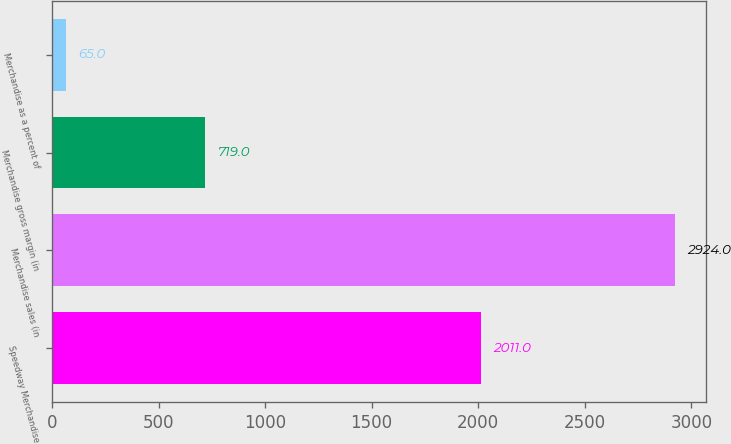Convert chart. <chart><loc_0><loc_0><loc_500><loc_500><bar_chart><fcel>Speedway Merchandise<fcel>Merchandise sales (in<fcel>Merchandise gross margin (in<fcel>Merchandise as a percent of<nl><fcel>2011<fcel>2924<fcel>719<fcel>65<nl></chart> 